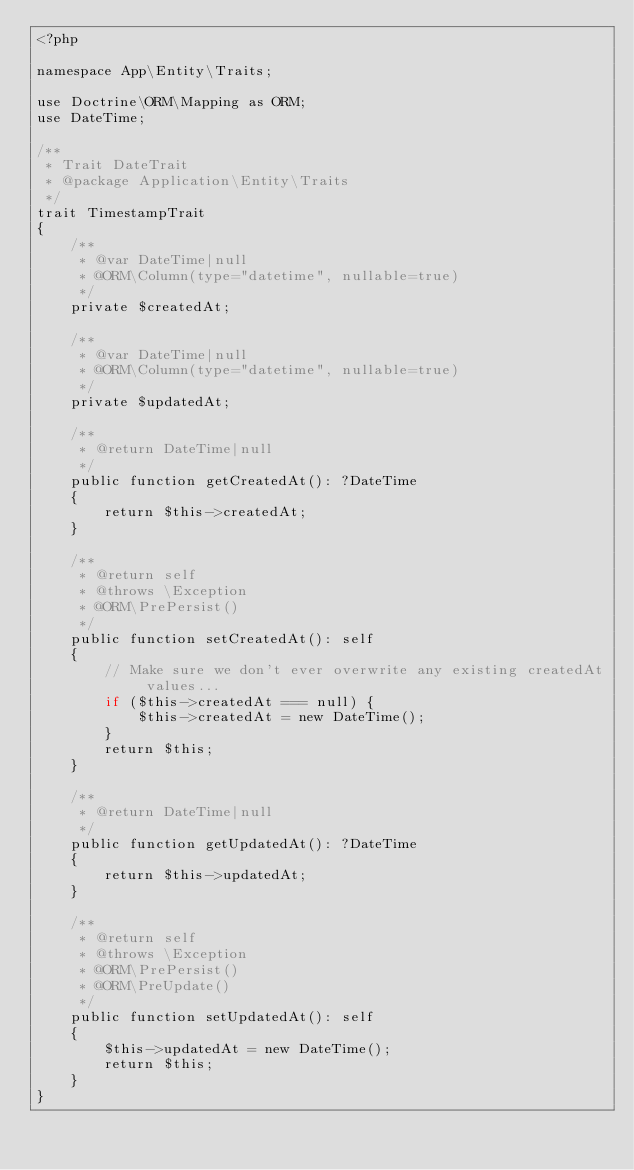Convert code to text. <code><loc_0><loc_0><loc_500><loc_500><_PHP_><?php

namespace App\Entity\Traits;

use Doctrine\ORM\Mapping as ORM;
use DateTime;

/**
 * Trait DateTrait
 * @package Application\Entity\Traits
 */
trait TimestampTrait
{
    /**
     * @var DateTime|null
     * @ORM\Column(type="datetime", nullable=true)
     */
    private $createdAt;

    /**
     * @var DateTime|null
     * @ORM\Column(type="datetime", nullable=true)
     */
    private $updatedAt;

    /**
     * @return DateTime|null
     */
    public function getCreatedAt(): ?DateTime
    {
        return $this->createdAt;
    }

    /**
     * @return self
     * @throws \Exception
     * @ORM\PrePersist()
     */
    public function setCreatedAt(): self
    {
        // Make sure we don't ever overwrite any existing createdAt values...
        if ($this->createdAt === null) {
            $this->createdAt = new DateTime();
        }
        return $this;
    }

    /**
     * @return DateTime|null
     */
    public function getUpdatedAt(): ?DateTime
    {
        return $this->updatedAt;
    }

    /**
     * @return self
     * @throws \Exception
     * @ORM\PrePersist()
     * @ORM\PreUpdate()
     */
    public function setUpdatedAt(): self
    {
        $this->updatedAt = new DateTime();
        return $this;
    }
}
</code> 